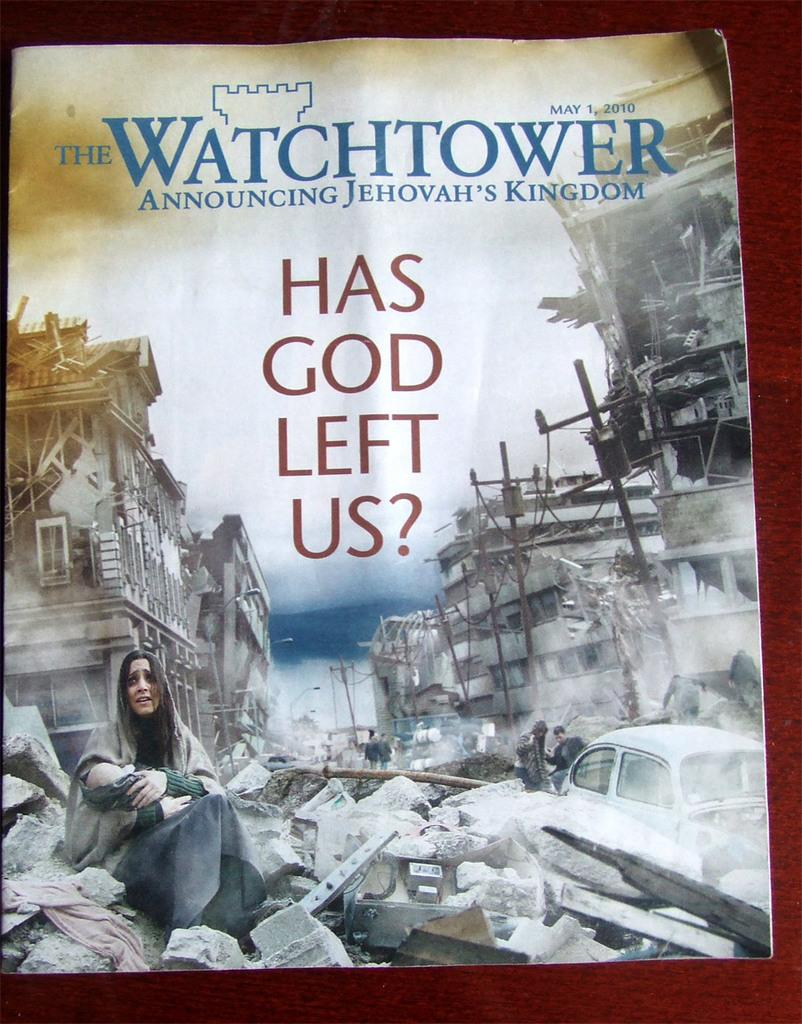Provide a one-sentence caption for the provided image. A Watchtower magazine titled "Has God Left Us?". 